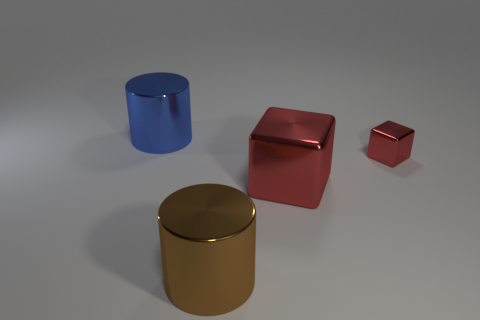Add 4 cyan balls. How many objects exist? 8 Add 2 large red shiny cubes. How many large red shiny cubes are left? 3 Add 4 gray things. How many gray things exist? 4 Subtract 0 yellow spheres. How many objects are left? 4 Subtract all small blue matte cylinders. Subtract all brown cylinders. How many objects are left? 3 